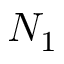<formula> <loc_0><loc_0><loc_500><loc_500>N _ { 1 }</formula> 